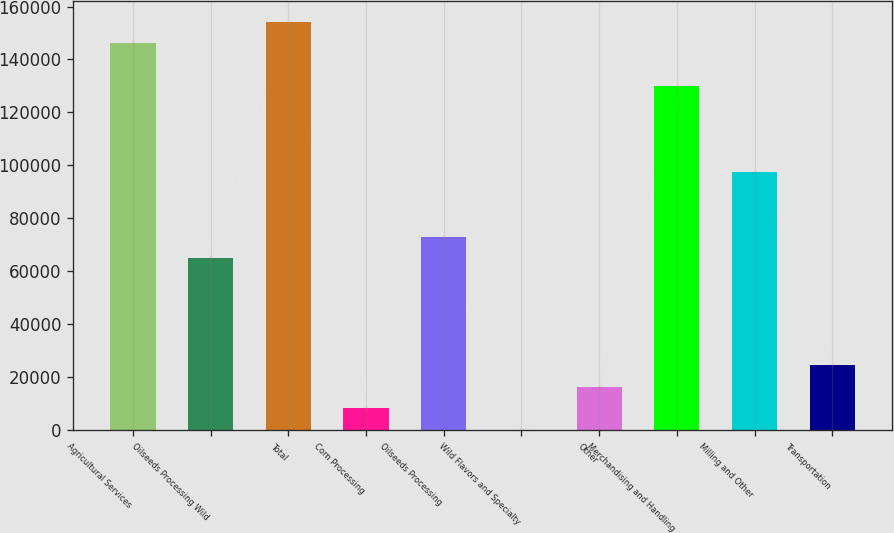Convert chart. <chart><loc_0><loc_0><loc_500><loc_500><bar_chart><fcel>Agricultural Services<fcel>Oilseeds Processing Wild<fcel>Total<fcel>Corn Processing<fcel>Oilseeds Processing<fcel>Wild Flavors and Specialty<fcel>Other<fcel>Merchandising and Handling<fcel>Milling and Other<fcel>Transportation<nl><fcel>146152<fcel>64963.2<fcel>154271<fcel>8130.9<fcel>73082.1<fcel>12<fcel>16249.8<fcel>129914<fcel>97438.8<fcel>24368.7<nl></chart> 